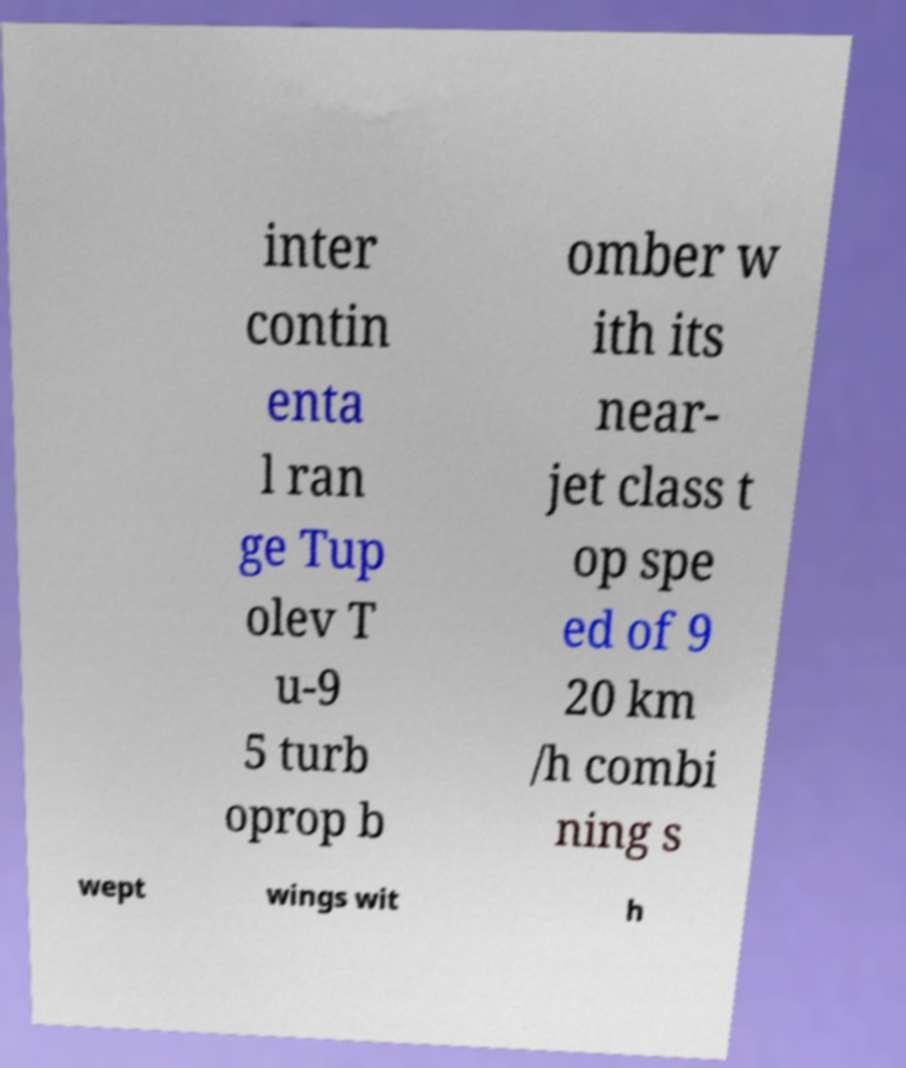Please identify and transcribe the text found in this image. inter contin enta l ran ge Tup olev T u-9 5 turb oprop b omber w ith its near- jet class t op spe ed of 9 20 km /h combi ning s wept wings wit h 